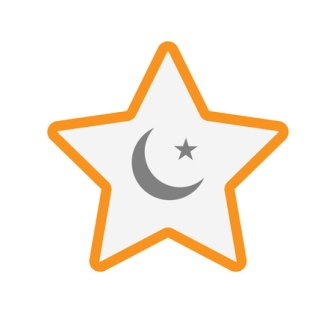Analyze the image in a comprehensive and detailed manner. The image showcases a prominent design centered on a celestial theme. At the center, there is a large, white star bordered by a vivid orange outline, creating a bold and eye-catching contrast. Within this major star, a smaller crescent moon is depicted in a subdued gray tone. The moon's placement around the heart of the star adds a serene and calming presence to the overall design. Adjacent to the moon is a tiny white star, enhancing the theme of the night sky and adding a secondary point of interest. The arrangement of the moon and tiny star within the larger star symbolically suggests harmony and balance, perhaps representing the relationship between different celestial bodies. The composition is visually appealing and symbolic, invoking thoughts of night and space with its tranquil and balanced imagery. 